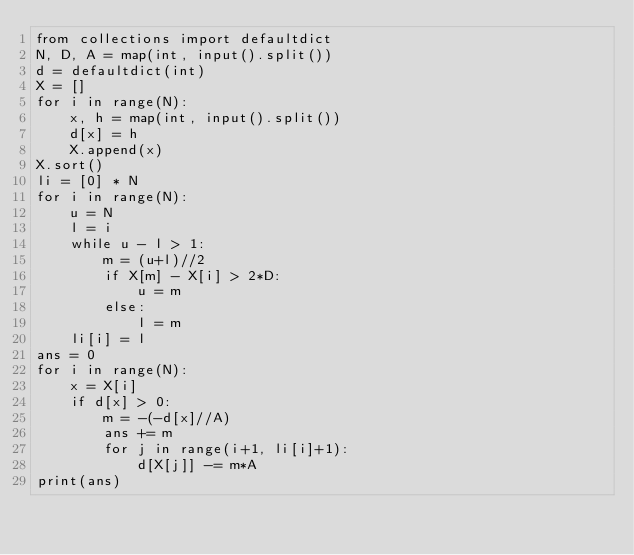Convert code to text. <code><loc_0><loc_0><loc_500><loc_500><_Python_>from collections import defaultdict
N, D, A = map(int, input().split())
d = defaultdict(int)
X = []
for i in range(N):
    x, h = map(int, input().split())
    d[x] = h
    X.append(x)
X.sort()
li = [0] * N
for i in range(N):
    u = N
    l = i
    while u - l > 1:
        m = (u+l)//2
        if X[m] - X[i] > 2*D:
            u = m
        else:
            l = m
    li[i] = l
ans = 0
for i in range(N):
    x = X[i]
    if d[x] > 0:
        m = -(-d[x]//A)
        ans += m
        for j in range(i+1, li[i]+1):
            d[X[j]] -= m*A
print(ans)</code> 